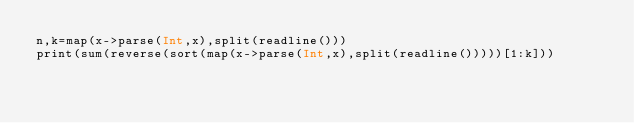<code> <loc_0><loc_0><loc_500><loc_500><_Julia_>n,k=map(x->parse(Int,x),split(readline()))
print(sum(reverse(sort(map(x->parse(Int,x),split(readline()))))[1:k]))</code> 